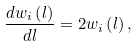Convert formula to latex. <formula><loc_0><loc_0><loc_500><loc_500>\frac { d w _ { i } \left ( l \right ) } { d l } = 2 w _ { i } \left ( l \right ) ,</formula> 